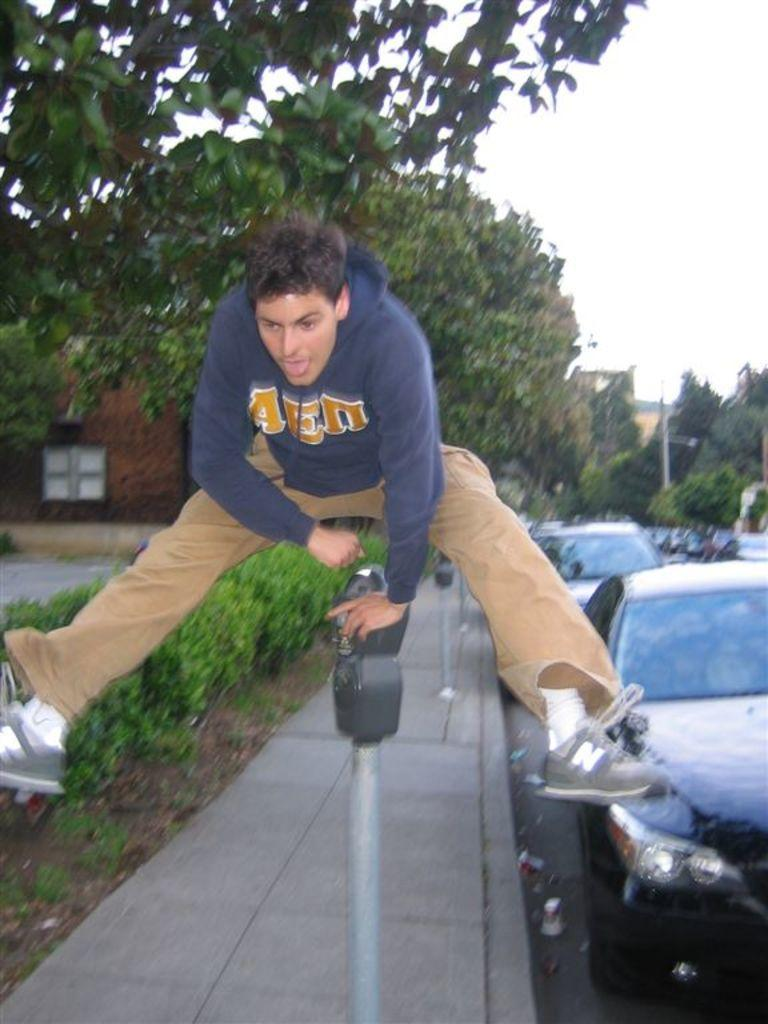What is the person in the image doing? There is a person jumping in the image. What else can be seen in the image besides the person? There are cars, trees, and buildings in the image. What type of volleyball is being offered to the person in the image? There is no volleyball present in the image. What record is being broken by the person in the image? There is no record-breaking activity depicted in the image. 